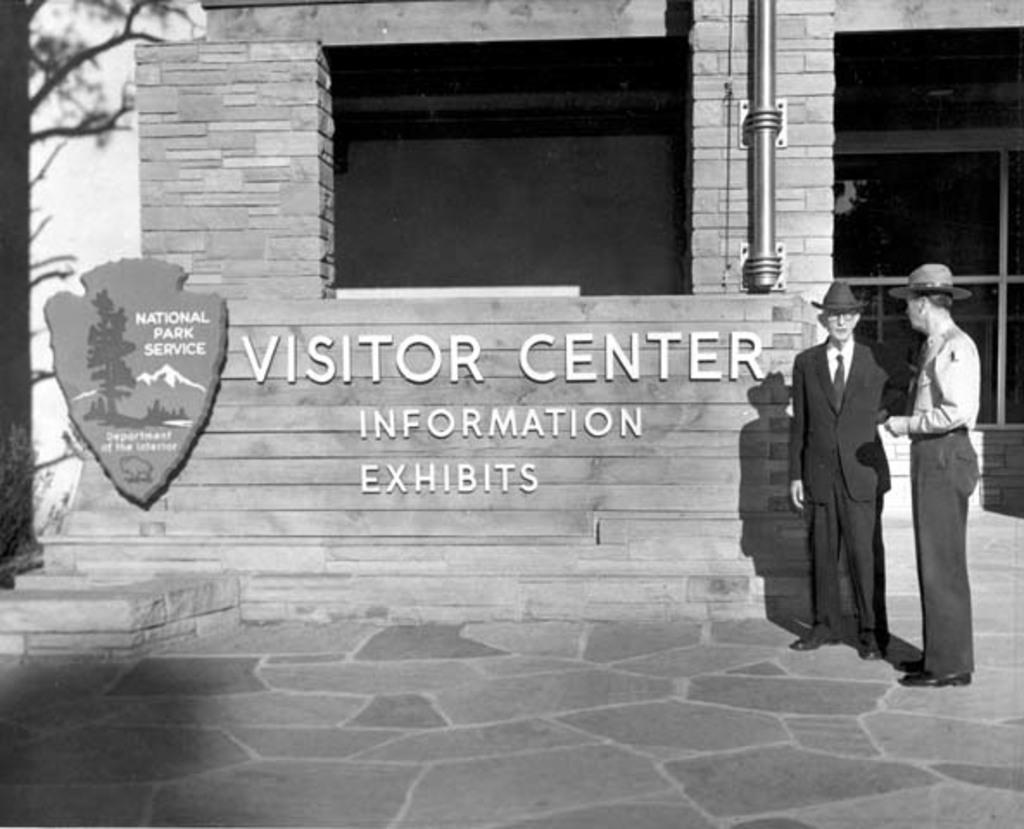What type of structure is visible in the image? There is a building in the image. What feature of the building can be seen in the image? There is a glass window in the building. What natural element is present in the image? There is a tree in the image. How many people are in the image? Two people are standing in the image. What is written or displayed on the wall in the image? There is something written on the wall in the image. What is the color scheme of the image? The image is in black and white. What type of animals can be seen at the zoo in the image? There is no zoo present in the image, so it is not possible to determine what animals might be seen. How much shade is provided by the tree in the image? The image is in black and white, so it is not possible to determine the amount of shade provided by the tree. 